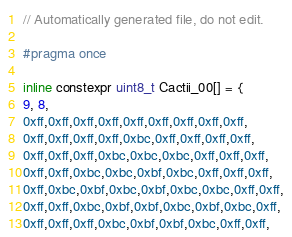<code> <loc_0><loc_0><loc_500><loc_500><_C_>// Automatically generated file, do not edit.

#pragma once

inline constexpr uint8_t Cactii_00[] = {
9, 8,
0xff,0xff,0xff,0xff,0xff,0xff,0xff,0xff,0xff,
0xff,0xff,0xff,0xff,0xbc,0xff,0xff,0xff,0xff,
0xff,0xff,0xff,0xbc,0xbc,0xbc,0xff,0xff,0xff,
0xff,0xff,0xbc,0xbc,0xbf,0xbc,0xff,0xff,0xff,
0xff,0xbc,0xbf,0xbc,0xbf,0xbc,0xbc,0xff,0xff,
0xff,0xff,0xbc,0xbf,0xbf,0xbc,0xbf,0xbc,0xff,
0xff,0xff,0xff,0xbc,0xbf,0xbf,0xbc,0xff,0xff,</code> 